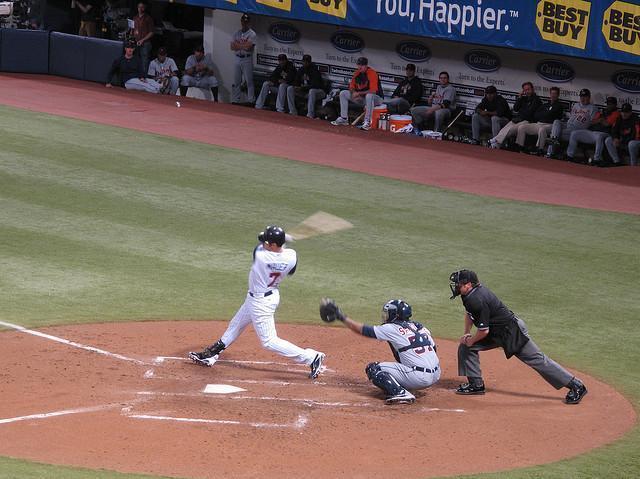How many people are visible?
Give a very brief answer. 5. How many people are wearing orange jackets?
Give a very brief answer. 0. 